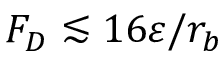Convert formula to latex. <formula><loc_0><loc_0><loc_500><loc_500>F _ { D } \lesssim 1 6 \varepsilon / r _ { b }</formula> 